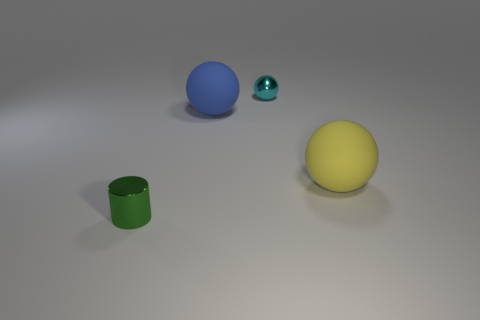There is another matte thing that is the same shape as the big blue object; what color is it?
Provide a succinct answer. Yellow. The cyan thing is what size?
Your response must be concise. Small. The matte thing on the left side of the shiny object that is behind the tiny metallic cylinder is what color?
Provide a succinct answer. Blue. How many balls are both behind the yellow sphere and in front of the tiny cyan metallic sphere?
Ensure brevity in your answer.  1. Are there more tiny red matte cubes than yellow matte objects?
Provide a succinct answer. No. What material is the tiny green object?
Provide a succinct answer. Metal. There is a big matte ball that is on the left side of the tiny cyan metallic thing; what number of small green cylinders are behind it?
Give a very brief answer. 0. There is a cylinder; does it have the same color as the sphere behind the big blue rubber sphere?
Provide a succinct answer. No. There is a object that is the same size as the blue rubber sphere; what color is it?
Give a very brief answer. Yellow. Is there a big green shiny object of the same shape as the big blue object?
Offer a terse response. No. 